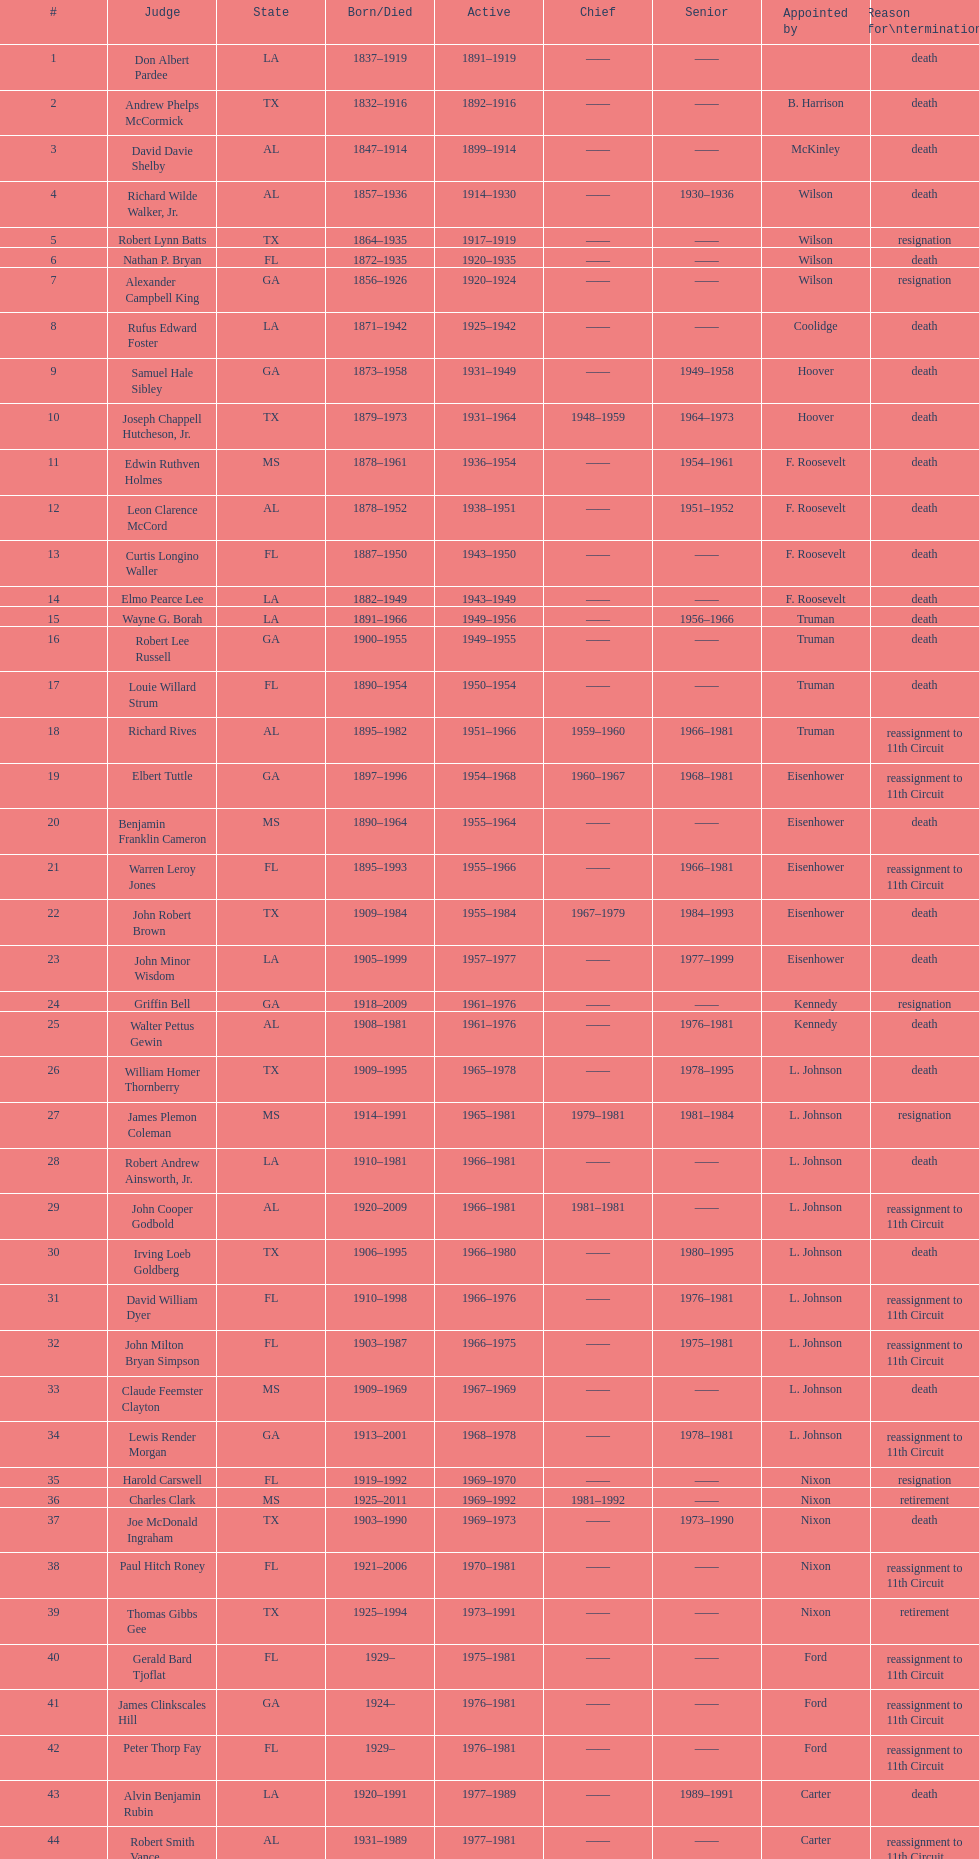During president carter's time in office, how many judges were appointed by him? 13. 